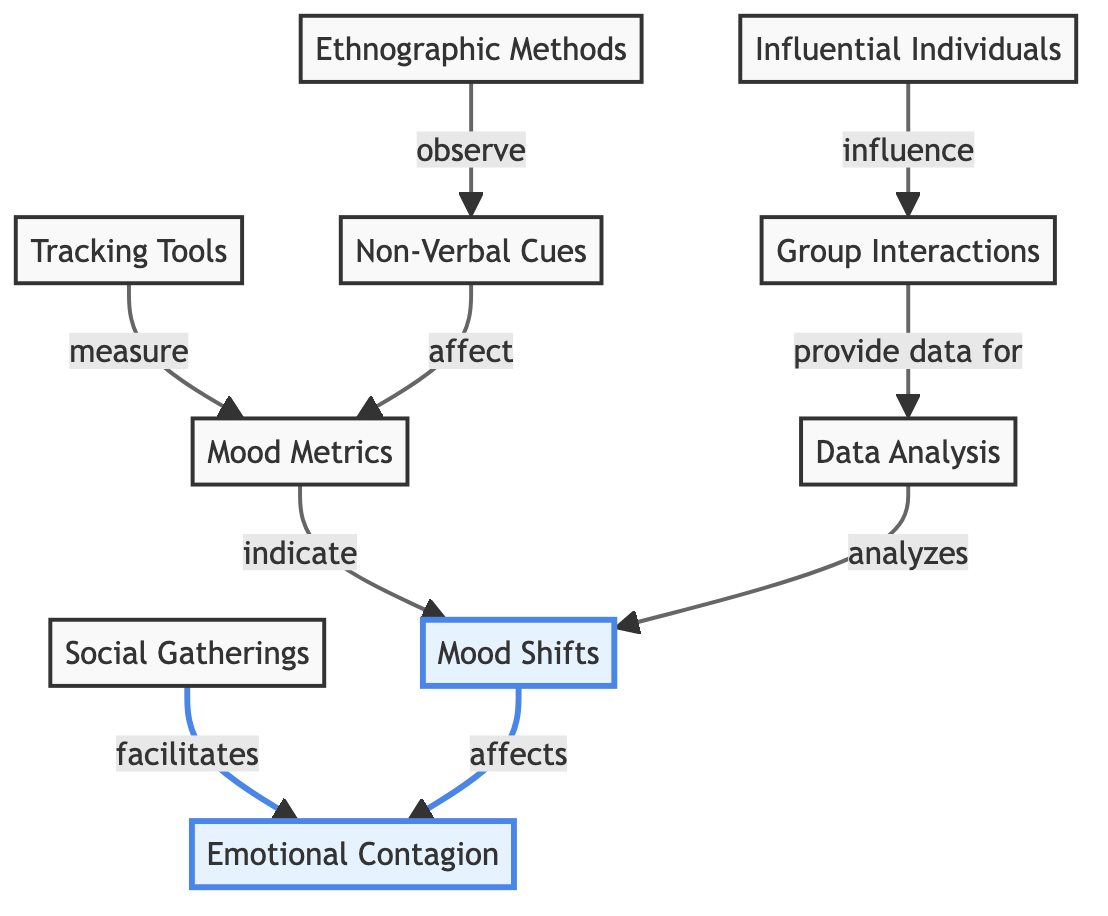what does "Mood Shifts" affect? The diagram indicates that "Mood Shifts" affects "Emotional Contagion." The arrow directly connecting these two nodes signifies this influence in the flowchart.
Answer: Emotional Contagion how many nodes are highlighted in the diagram? The diagram contains four highlighted nodes, which are "Mood Shifts," "Emotional Contagion," "Tracking Tools," and "Influential Individuals." By counting the highlighted elements, we arrive at this number.
Answer: Four what do "Tracking Tools" measure? The connection in the diagram shows that "Tracking Tools" measure "Mood Metrics." The directional arrow illustrates this relationship clearly.
Answer: Mood Metrics which node observes non-verbal cues? The diagram displays that "Ethnographic Methods" observes "Non-Verbal Cues." This is indicated by the arrow pointing from "Ethnographic Methods" to "Non-Verbal Cues."
Answer: Ethnographic Methods how does "Non-Verbal Cues" affect "Mood Metrics"? "Non-Verbal Cues" affects "Mood Metrics," as evidenced by the direct arrow linking these two nodes. This indicates a directional influence in the diagram.
Answer: Mood Metrics what are the two main nodes connected to "Group Interactions"? The nodes connected to "Group Interactions" are "Influential Individuals" and "Data Analysis." By observing the arrows emanating from "Group Interactions," these connections are identified.
Answer: Influential Individuals and Data Analysis which node provides data for "Data Analysis"? The diagram shows that "Group Interactions" provides data for "Data Analysis," illustrated by the directional arrow that connects these two nodes.
Answer: Group Interactions how many influences are indicated in the diagram? The diagram shows five influences indicated by arrows between the various nodes. By counting the arrows pointing to and from different nodes, this total is determined.
Answer: Five 